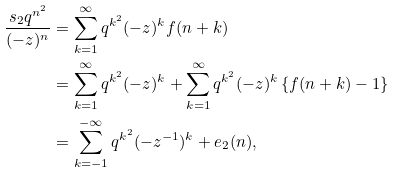Convert formula to latex. <formula><loc_0><loc_0><loc_500><loc_500>\frac { s _ { 2 } q ^ { n ^ { 2 } } } { ( - z ) ^ { n } } & = \sum _ { k = 1 } ^ { \infty } q ^ { k ^ { 2 } } ( - z ) ^ { k } f ( n + k ) \\ & = \sum _ { k = 1 } ^ { \infty } q ^ { k ^ { 2 } } ( - z ) ^ { k } + \sum _ { k = 1 } ^ { \infty } q ^ { k ^ { 2 } } ( - z ) ^ { k } \left \{ f ( n + k ) - 1 \right \} \\ & = \sum _ { k = - 1 } ^ { - \infty } q ^ { k ^ { 2 } } ( - z ^ { - 1 } ) ^ { k } + e _ { 2 } ( n ) ,</formula> 